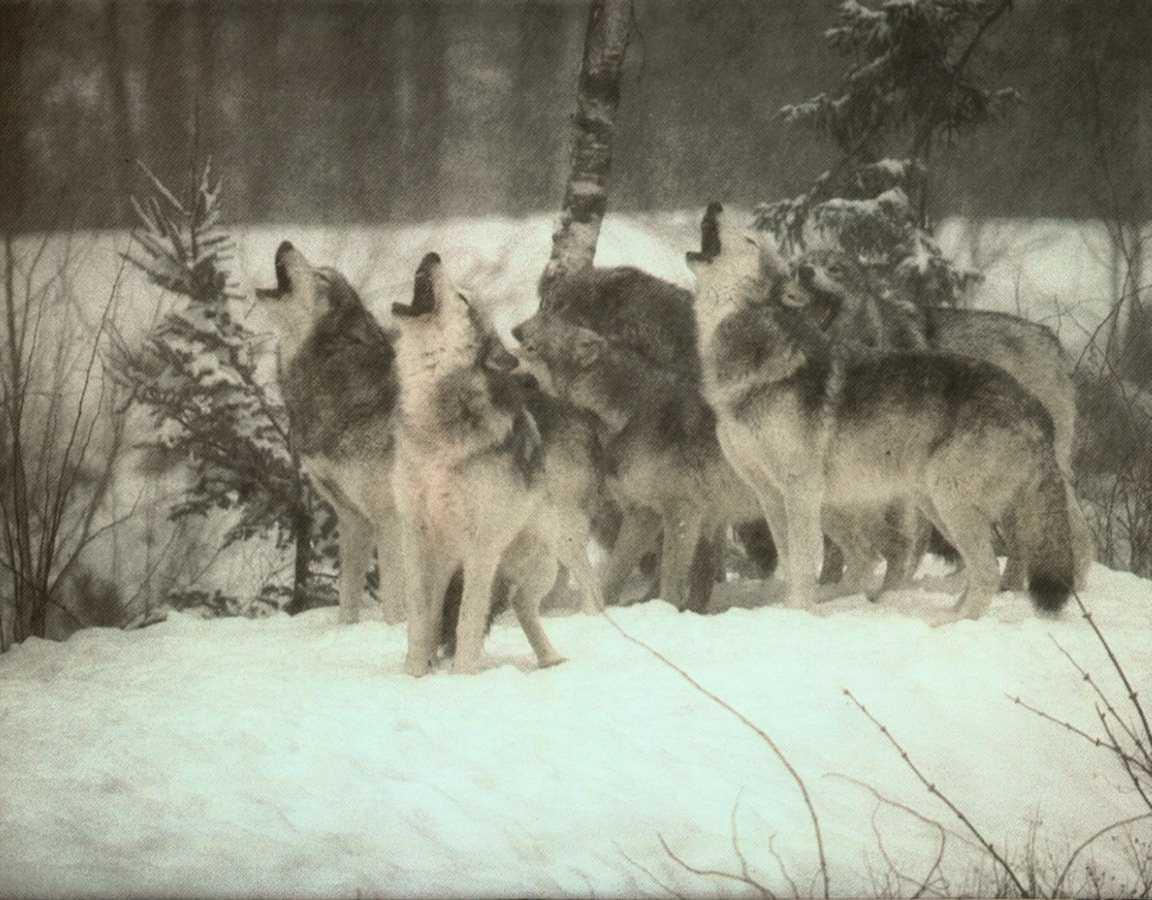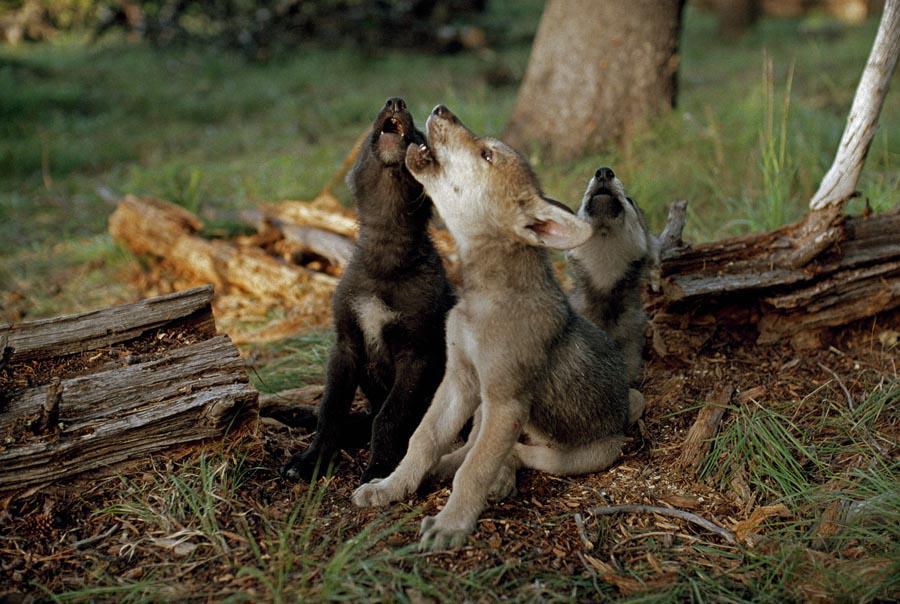The first image is the image on the left, the second image is the image on the right. For the images shown, is this caption "One image contains only non-howling wolves with non-raised heads, and the other image includes wolves howling with raised heads." true? Answer yes or no. No. The first image is the image on the left, the second image is the image on the right. Analyze the images presented: Is the assertion "The right image contains five wolves." valid? Answer yes or no. No. 